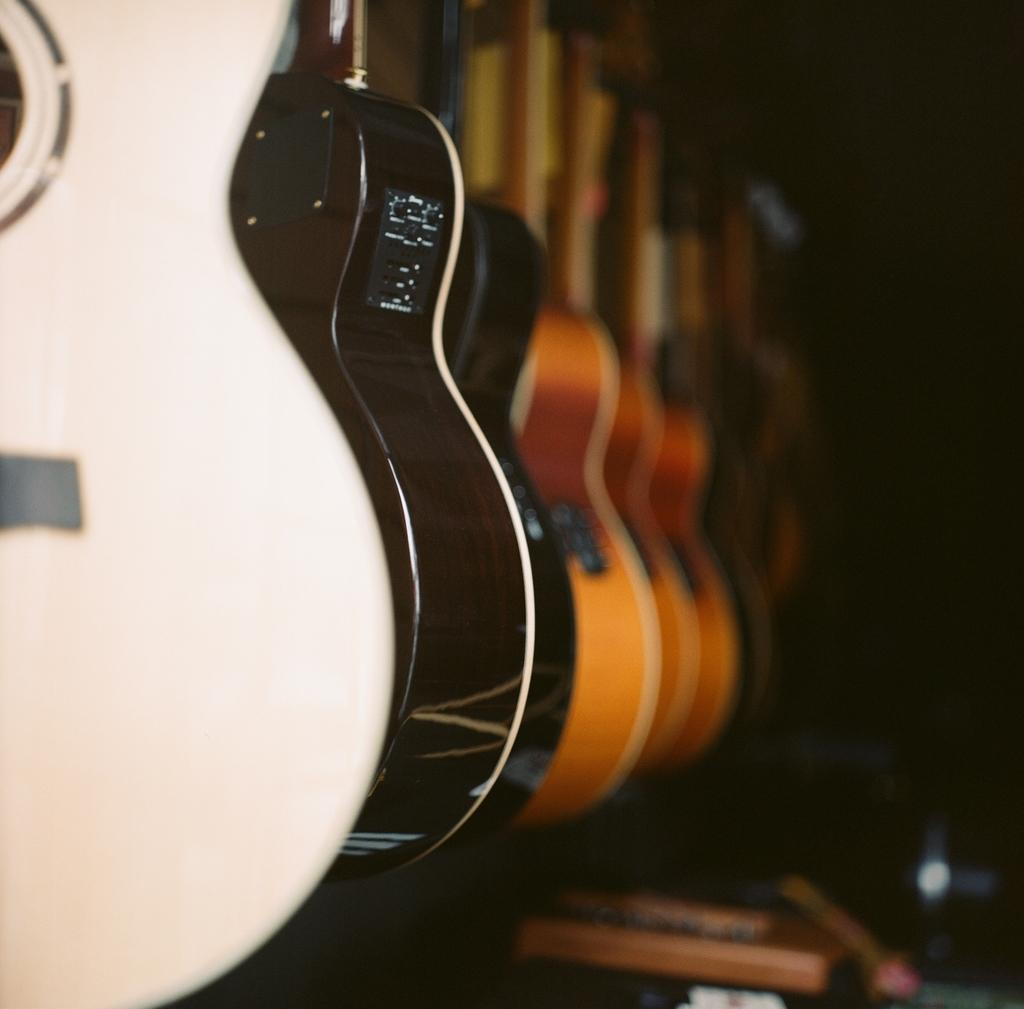What musical instruments are present in the image? There are guitars in the image. What can be observed about the background of the image? The background of the image is dark. How many fangs can be seen on the guitars in the image? There are no fangs present on the guitars in the image, as guitars do not have fangs. 